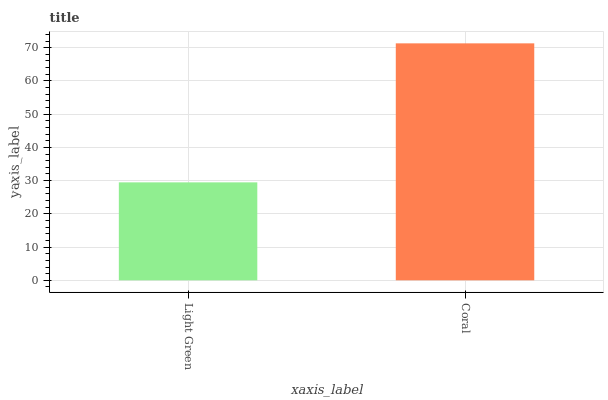Is Light Green the minimum?
Answer yes or no. Yes. Is Coral the maximum?
Answer yes or no. Yes. Is Coral the minimum?
Answer yes or no. No. Is Coral greater than Light Green?
Answer yes or no. Yes. Is Light Green less than Coral?
Answer yes or no. Yes. Is Light Green greater than Coral?
Answer yes or no. No. Is Coral less than Light Green?
Answer yes or no. No. Is Coral the high median?
Answer yes or no. Yes. Is Light Green the low median?
Answer yes or no. Yes. Is Light Green the high median?
Answer yes or no. No. Is Coral the low median?
Answer yes or no. No. 